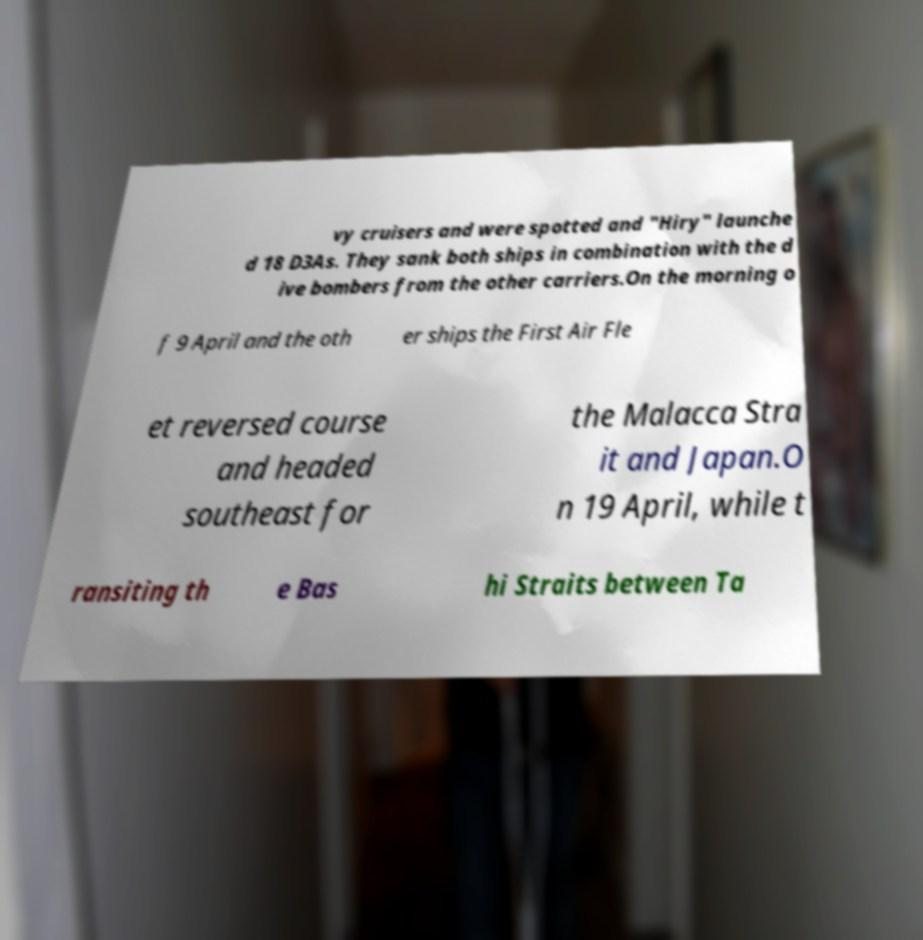Can you read and provide the text displayed in the image?This photo seems to have some interesting text. Can you extract and type it out for me? vy cruisers and were spotted and "Hiry" launche d 18 D3As. They sank both ships in combination with the d ive bombers from the other carriers.On the morning o f 9 April and the oth er ships the First Air Fle et reversed course and headed southeast for the Malacca Stra it and Japan.O n 19 April, while t ransiting th e Bas hi Straits between Ta 